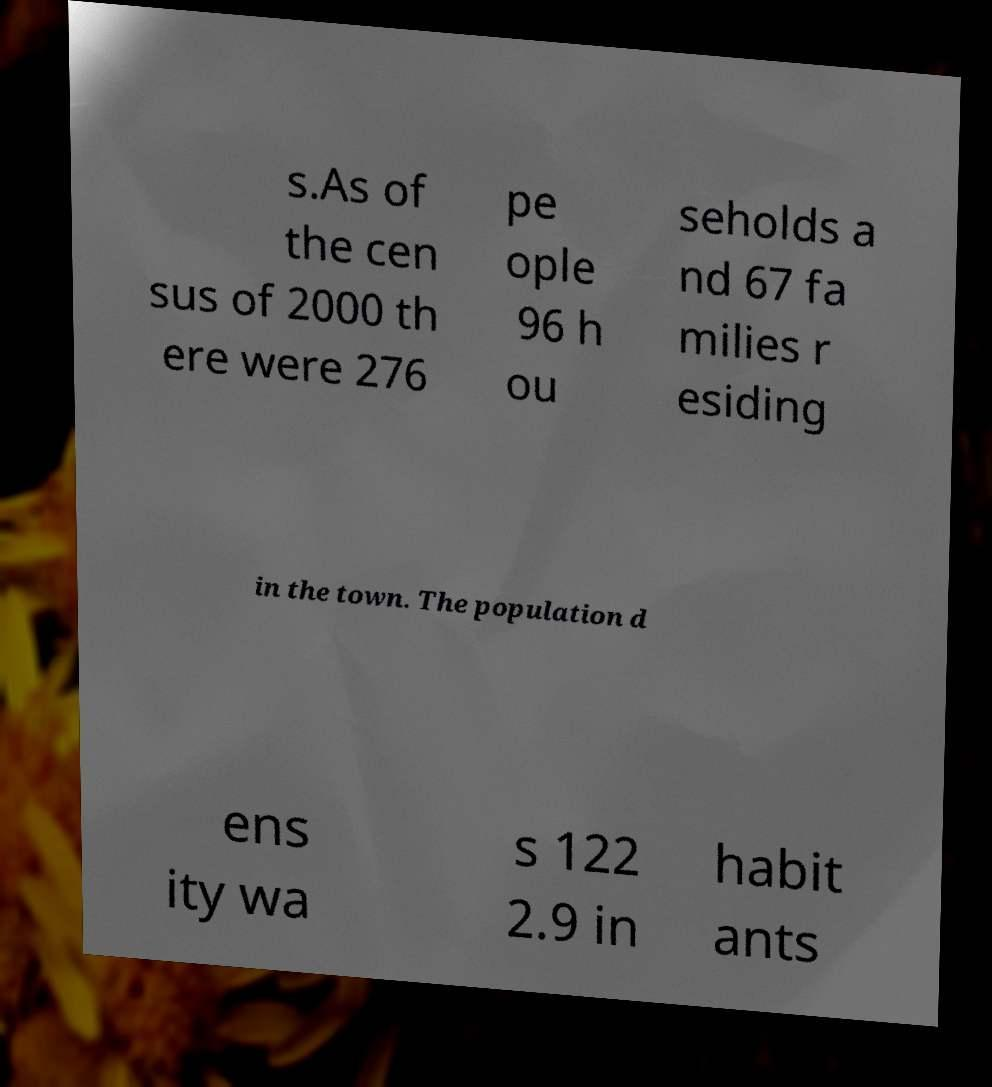Could you assist in decoding the text presented in this image and type it out clearly? s.As of the cen sus of 2000 th ere were 276 pe ople 96 h ou seholds a nd 67 fa milies r esiding in the town. The population d ens ity wa s 122 2.9 in habit ants 